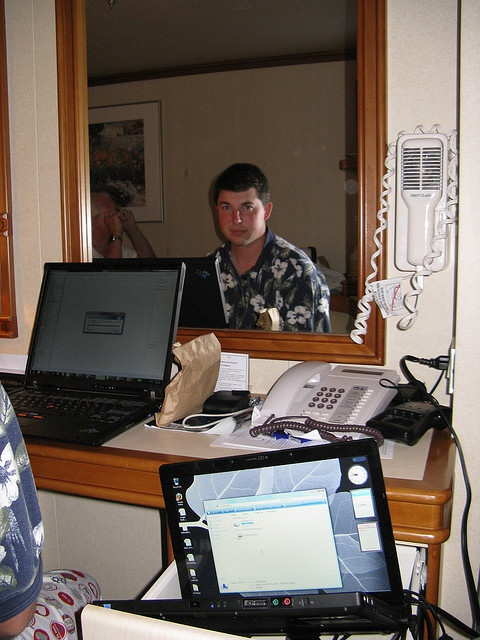Describe the objects in this image and their specific colors. I can see laptop in maroon, black, lightgray, lightblue, and darkgray tones, laptop in maroon, black, and purple tones, people in maroon, black, and gray tones, people in maroon, gray, darkgray, and lightgray tones, and people in maroon, black, and gray tones in this image. 